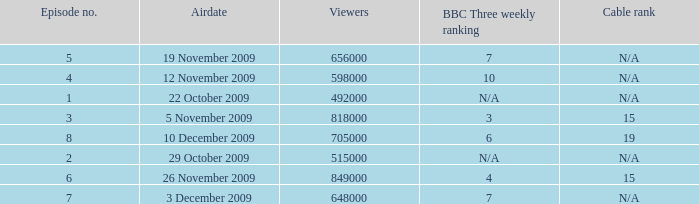What is the cable rank for the airdate of 10 december 2009? 19.0. 